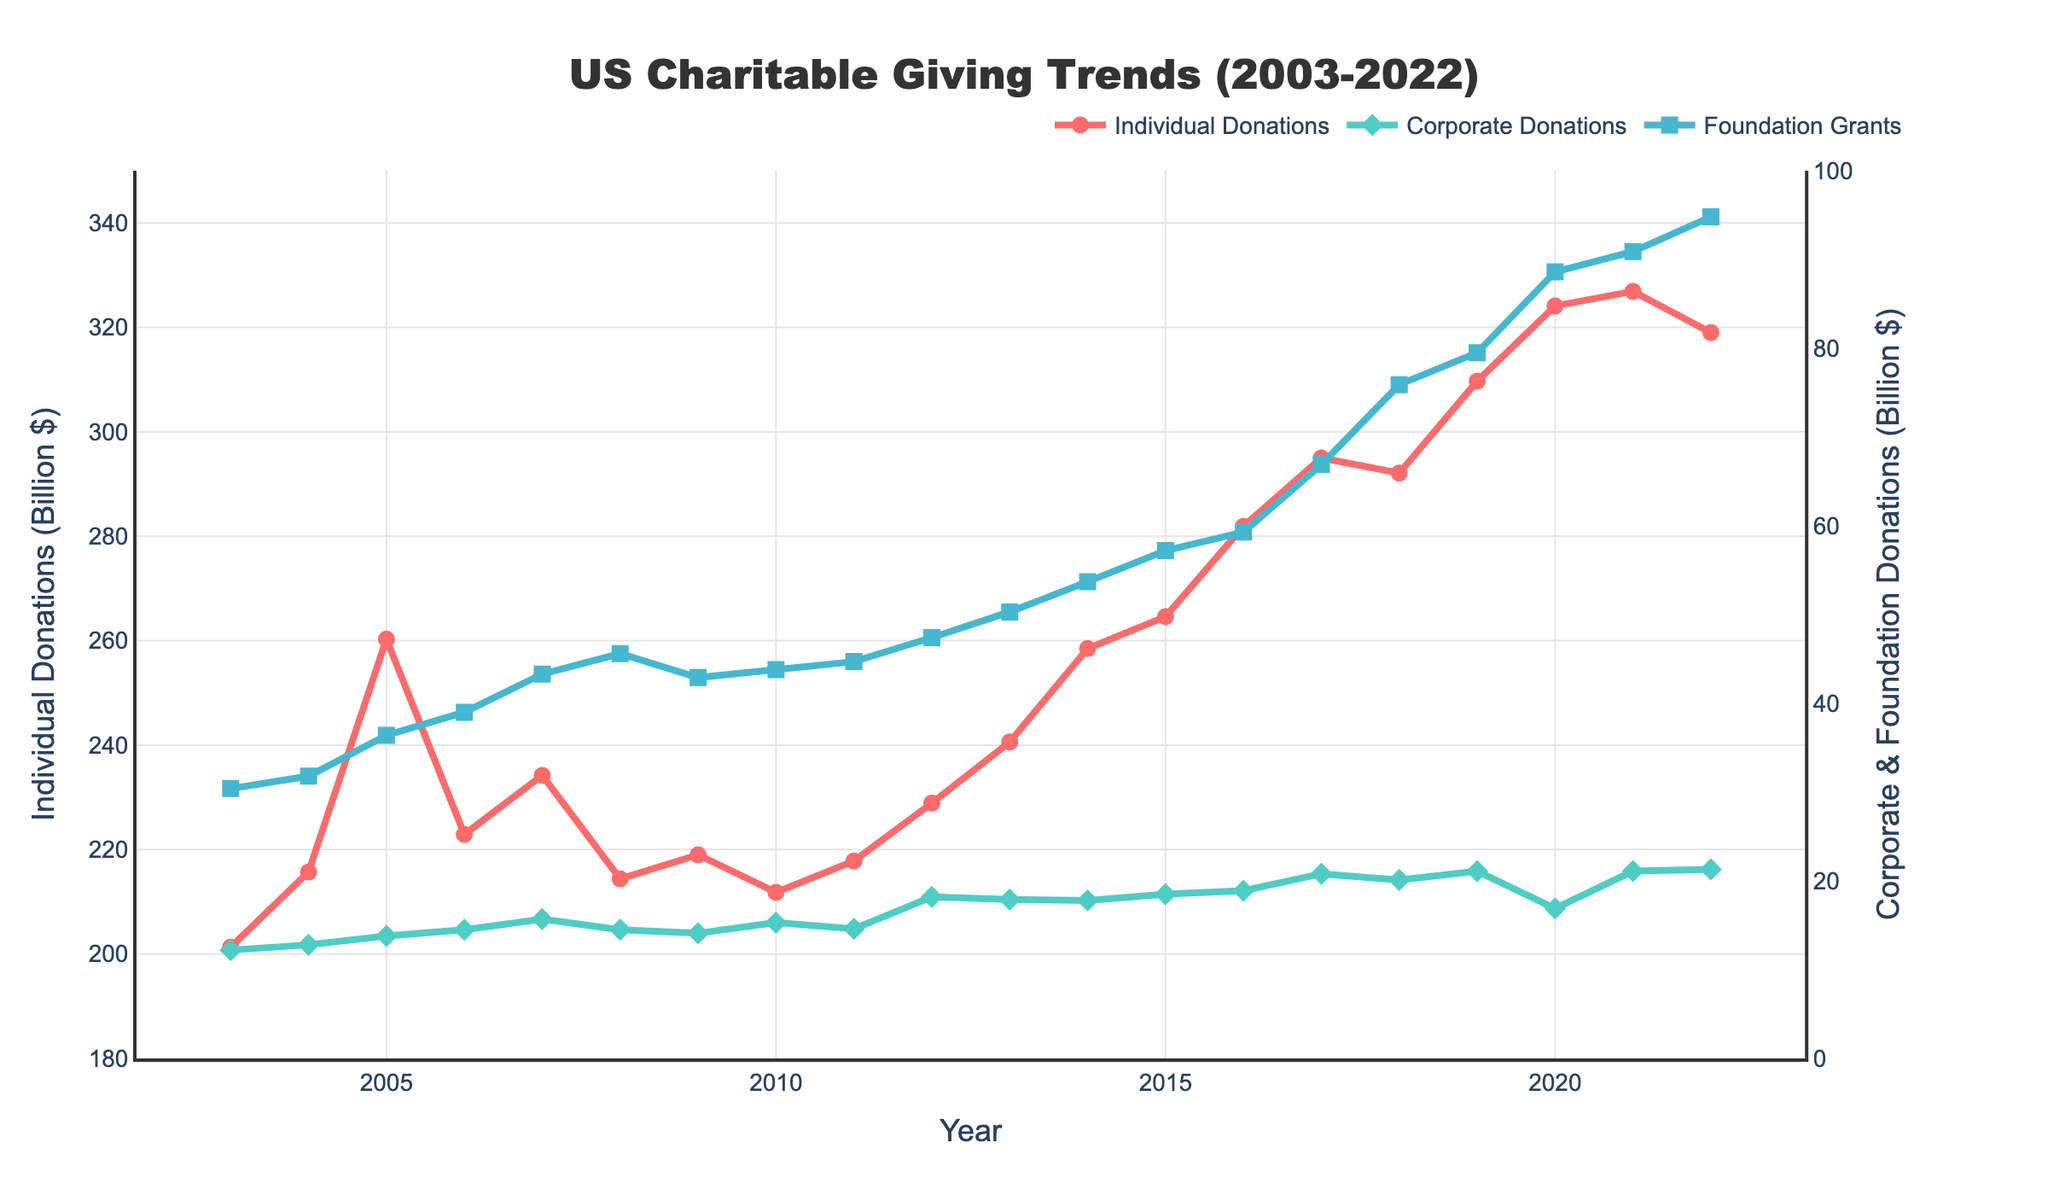What's the highest value for Individual Donations and when did it occur? The highest point in the line for Individual Donations is the peak value. Based on the figure, it occurs in 2021 with a value of 326.9 billion dollars.
Answer: 326.9 billion dollars in 2021 How did Corporate Donations change between 2019 and 2020? From the figure, observe the green line representing Corporate Donations. In 2019, the value was 21.1 billion dollars, and it decreased to 16.9 billion dollars in 2020. The change is 21.1 - 16.9 = 4.2 billion dollars.
Answer: Decreased by 4.2 billion dollars What is the average amount of Foundation Grants from 2018 to 2022? To calculate the average, sum the values of Foundation Grants from 2018 to 2022 and divide by the number of years. The values are 75.9, 79.5, 88.6, 90.9, and 94.8 billion dollars. Sum: 75.9 + 79.5 + 88.6 + 90.9 + 94.8 = 429.7. Average: 429.7 / 5 = 85.94 billion dollars.
Answer: 85.94 billion dollars Between which consecutive years did Individual Donations see the largest increase? To find the largest increase, look for the steepest upward slope in the line representing Individual Donations. The largest increase occurs between 2004 (215.7 billion) and 2005 (260.3 billion). Increase: 260.3 - 215.7 = 44.6 billion dollars.
Answer: Between 2004 and 2005 Which type of donation shows the most consistent growth over the 20 years? By examining the overall trends visually, the blue line representing Foundation Grants shows a consistent upward trend without major dips. Both Individual and Corporate Donations show periods of decrease.
Answer: Foundation Grants What was the combined value of Corporate Donations and Foundation Grants in 2012? Sum the values of Corporate Donations and Foundation Grants for 2012. Corporate: 18.2 billion, Foundation: 47.4 billion. Combined: 18.2 + 47.4 = 65.6 billion dollars.
Answer: 65.6 billion dollars Compare the trends of Corporate and Individual Donations during the 2008 financial crisis. In 2008, Individual Donations dropped from 234.2 billion dollars (2007) to 214.4 billion dollars (2008), indicating a decrease. Corporate Donations also declined from 15.7 billion dollars to 14.5 billion dollars. Both types of donations decreased.
Answer: Both decreased During which years did all three types of donations increase simultaneously? Identify intervals where all three lines increase year over year. From 2006 to 2007, Individual, Corporate, and Foundation donations all increased. From 2014 to 2015 and 2016 to 2017, all three types also increased.
Answer: 2006-2007, 2014-2015, 2016-2017 